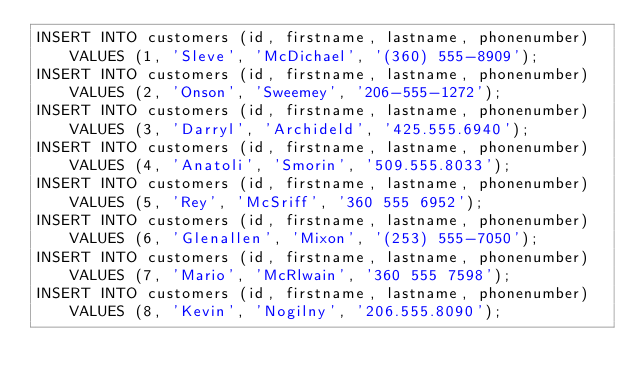<code> <loc_0><loc_0><loc_500><loc_500><_SQL_>INSERT INTO customers (id, firstname, lastname, phonenumber) VALUES (1, 'Sleve', 'McDichael', '(360) 555-8909');
INSERT INTO customers (id, firstname, lastname, phonenumber) VALUES (2, 'Onson', 'Sweemey', '206-555-1272');
INSERT INTO customers (id, firstname, lastname, phonenumber) VALUES (3, 'Darryl', 'Archideld', '425.555.6940');
INSERT INTO customers (id, firstname, lastname, phonenumber) VALUES (4, 'Anatoli', 'Smorin', '509.555.8033');
INSERT INTO customers (id, firstname, lastname, phonenumber) VALUES (5, 'Rey', 'McSriff', '360 555 6952');
INSERT INTO customers (id, firstname, lastname, phonenumber) VALUES (6, 'Glenallen', 'Mixon', '(253) 555-7050');
INSERT INTO customers (id, firstname, lastname, phonenumber) VALUES (7, 'Mario', 'McRlwain', '360 555 7598');
INSERT INTO customers (id, firstname, lastname, phonenumber) VALUES (8, 'Kevin', 'Nogilny', '206.555.8090');</code> 